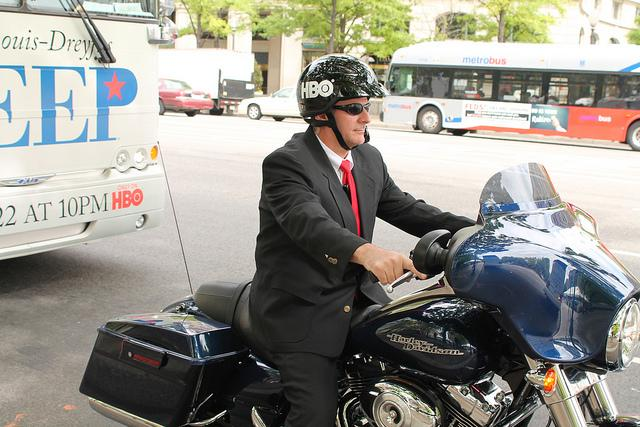The man on the motorcycle is pretending to act as what type of person? police 